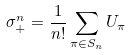<formula> <loc_0><loc_0><loc_500><loc_500>\sigma _ { + } ^ { n } = \frac { 1 } { n ! } \sum _ { \pi \in S _ { n } } U _ { \pi }</formula> 